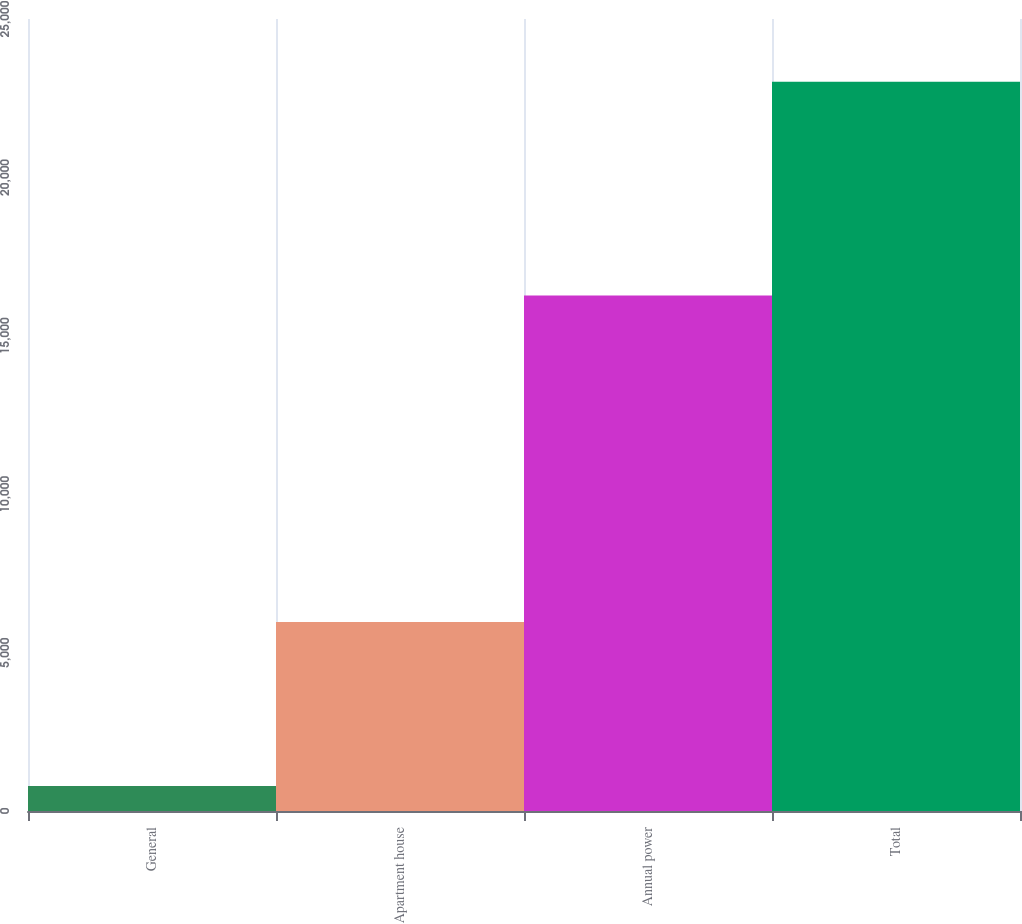<chart> <loc_0><loc_0><loc_500><loc_500><bar_chart><fcel>General<fcel>Apartment house<fcel>Annual power<fcel>Total<nl><fcel>786<fcel>5962<fcel>16269<fcel>23017<nl></chart> 